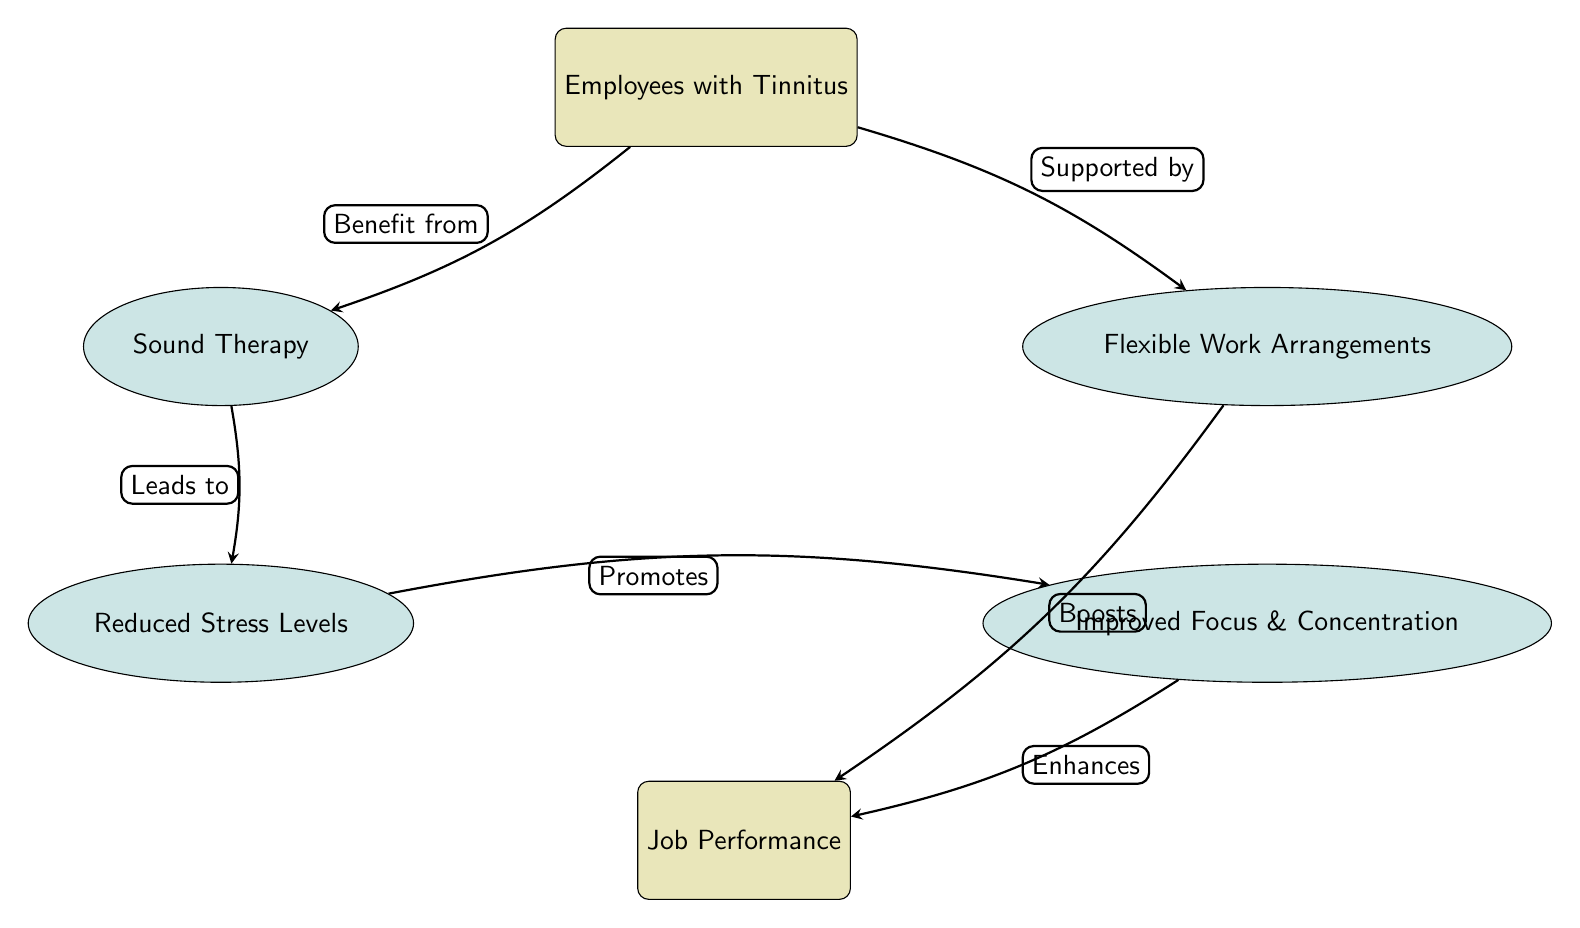What type of therapy is beneficial for employees with tinnitus? The diagram indicates that "Sound Therapy" is the type of therapy that "Employees with Tinnitus" benefit from, as shown in the first directed edge from employees to sound.
Answer: Sound Therapy What two benefits lead to improved job performance? The diagram shows "Reduced Stress Levels" and "Improved Focus & Concentration" as the benefits that lead to "Job Performance," represented by directional arrows connecting these nodes.
Answer: Reduced Stress Levels, Improved Focus & Concentration What do flexible work arrangements support? According to the diagram, "Flexible Work Arrangements" support "Employees with Tinnitus," as indicated by the directed edge from flexible to employees.
Answer: Employees with Tinnitus How many main nodes are present in the diagram? There are three main nodes: "Employees with Tinnitus," "Job Performance," and "Flexible Work Arrangements." By counting only the rectangles representing main nodes, we reach the total.
Answer: 3 What does sound therapy lead to in terms of stress? The arrow from "Sound Therapy" to "Reduced Stress Levels" in the diagram indicates that it leads directly to this outcome.
Answer: Reduced Stress Levels Which node represents the ultimate goal in terms of job performance? The "Job Performance" node is located at the bottom of the diagram, showcasing it as the final outcome or goal that is improved by other nodes.
Answer: Job Performance How does improved focus and concentration affect job performance? According to the diagram, "Improved Focus & Concentration" enhances "Job Performance," indicating a positive impact as shown by the directed edge.
Answer: Enhances What is the relationship between stress levels and focus? The diagram reveals that "Reduced Stress Levels" promotes "Improved Focus & Concentration," which indicates a direct positive relationship between these two nodes.
Answer: Promotes What is the effect of flexibility on job performance? The diagram specifies that "Flexible Work Arrangements" boost "Job Performance," representing a significant positive effect depicted by the directed edge.
Answer: Boosts 